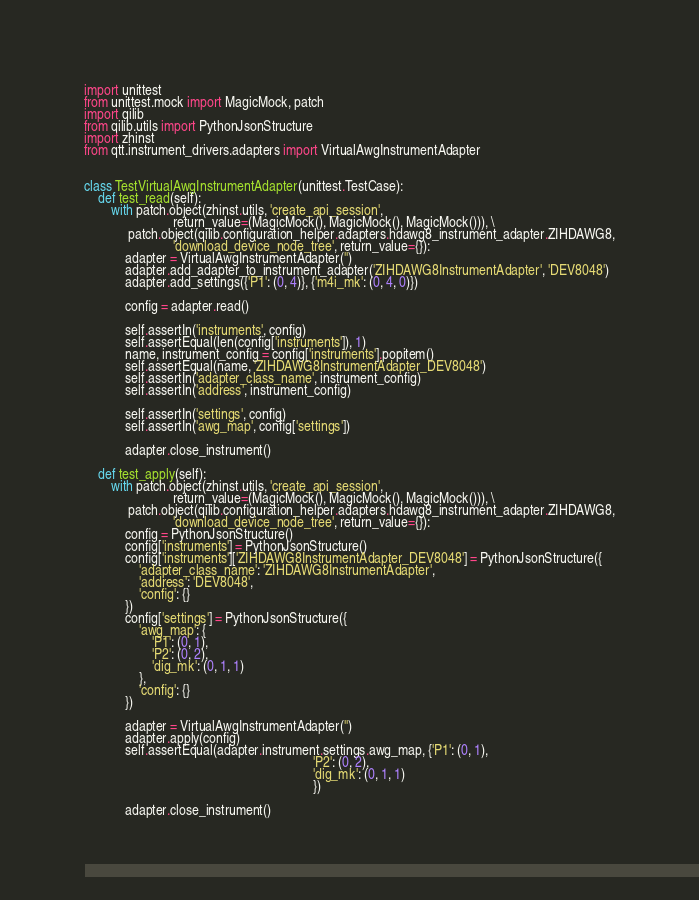Convert code to text. <code><loc_0><loc_0><loc_500><loc_500><_Python_>import unittest
from unittest.mock import MagicMock, patch
import qilib
from qilib.utils import PythonJsonStructure
import zhinst
from qtt.instrument_drivers.adapters import VirtualAwgInstrumentAdapter


class TestVirtualAwgInstrumentAdapter(unittest.TestCase):
    def test_read(self):
        with patch.object(zhinst.utils, 'create_api_session',
                          return_value=(MagicMock(), MagicMock(), MagicMock())), \
             patch.object(qilib.configuration_helper.adapters.hdawg8_instrument_adapter.ZIHDAWG8,
                          'download_device_node_tree', return_value={}):
            adapter = VirtualAwgInstrumentAdapter('')
            adapter.add_adapter_to_instrument_adapter('ZIHDAWG8InstrumentAdapter', 'DEV8048')
            adapter.add_settings({'P1': (0, 4)}, {'m4i_mk': (0, 4, 0)})

            config = adapter.read()

            self.assertIn('instruments', config)
            self.assertEqual(len(config['instruments']), 1)
            name, instrument_config = config['instruments'].popitem()
            self.assertEqual(name, 'ZIHDAWG8InstrumentAdapter_DEV8048')
            self.assertIn('adapter_class_name', instrument_config)
            self.assertIn('address', instrument_config)

            self.assertIn('settings', config)
            self.assertIn('awg_map', config['settings'])

            adapter.close_instrument()

    def test_apply(self):
        with patch.object(zhinst.utils, 'create_api_session',
                          return_value=(MagicMock(), MagicMock(), MagicMock())), \
             patch.object(qilib.configuration_helper.adapters.hdawg8_instrument_adapter.ZIHDAWG8,
                          'download_device_node_tree', return_value={}):
            config = PythonJsonStructure()
            config['instruments'] = PythonJsonStructure()
            config['instruments']['ZIHDAWG8InstrumentAdapter_DEV8048'] = PythonJsonStructure({
                'adapter_class_name': 'ZIHDAWG8InstrumentAdapter',
                'address': 'DEV8048',
                'config': {}
            })
            config['settings'] = PythonJsonStructure({
                'awg_map': {
                    'P1': (0, 1),
                    'P2': (0, 2),
                    'dig_mk': (0, 1, 1)
                },
                'config': {}
            })

            adapter = VirtualAwgInstrumentAdapter('')
            adapter.apply(config)
            self.assertEqual(adapter.instrument.settings.awg_map, {'P1': (0, 1),
                                                                   'P2': (0, 2),
                                                                   'dig_mk': (0, 1, 1)
                                                                   })

            adapter.close_instrument()
</code> 